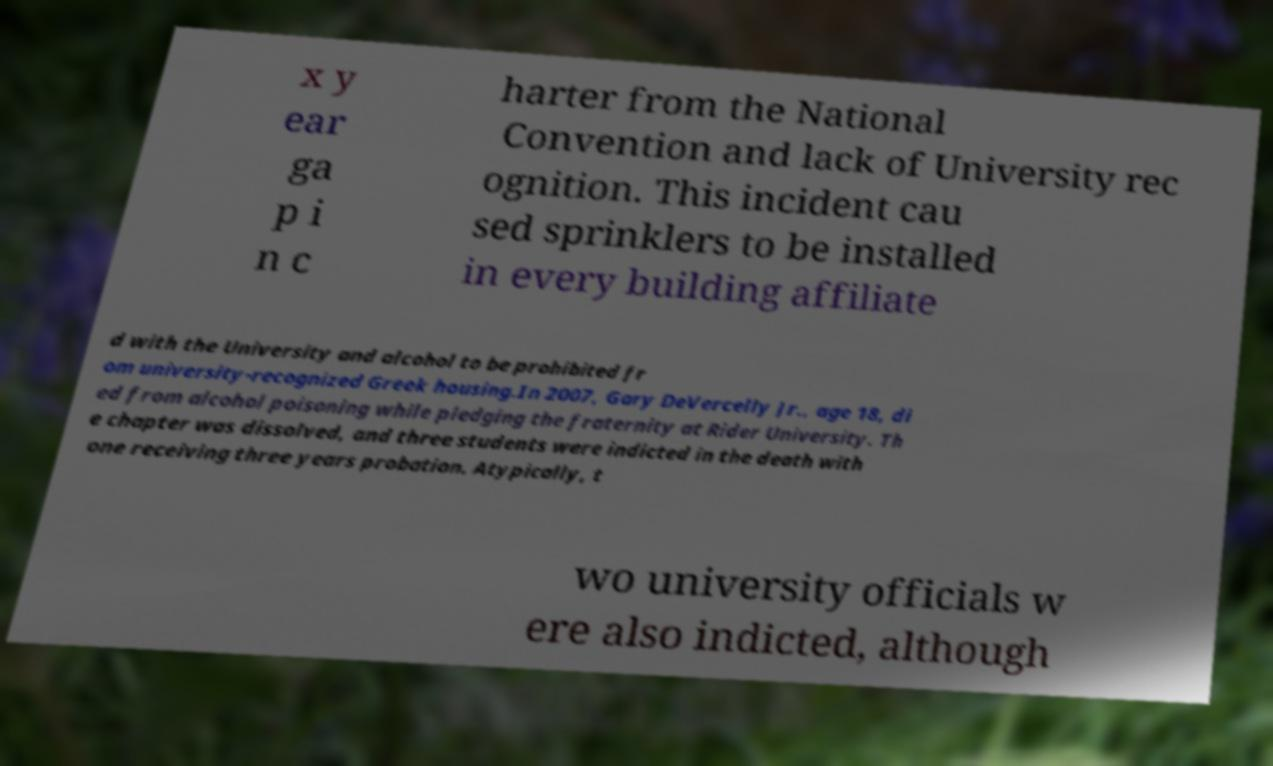What messages or text are displayed in this image? I need them in a readable, typed format. x y ear ga p i n c harter from the National Convention and lack of University rec ognition. This incident cau sed sprinklers to be installed in every building affiliate d with the University and alcohol to be prohibited fr om university-recognized Greek housing.In 2007, Gary DeVercelly Jr., age 18, di ed from alcohol poisoning while pledging the fraternity at Rider University. Th e chapter was dissolved, and three students were indicted in the death with one receiving three years probation. Atypically, t wo university officials w ere also indicted, although 